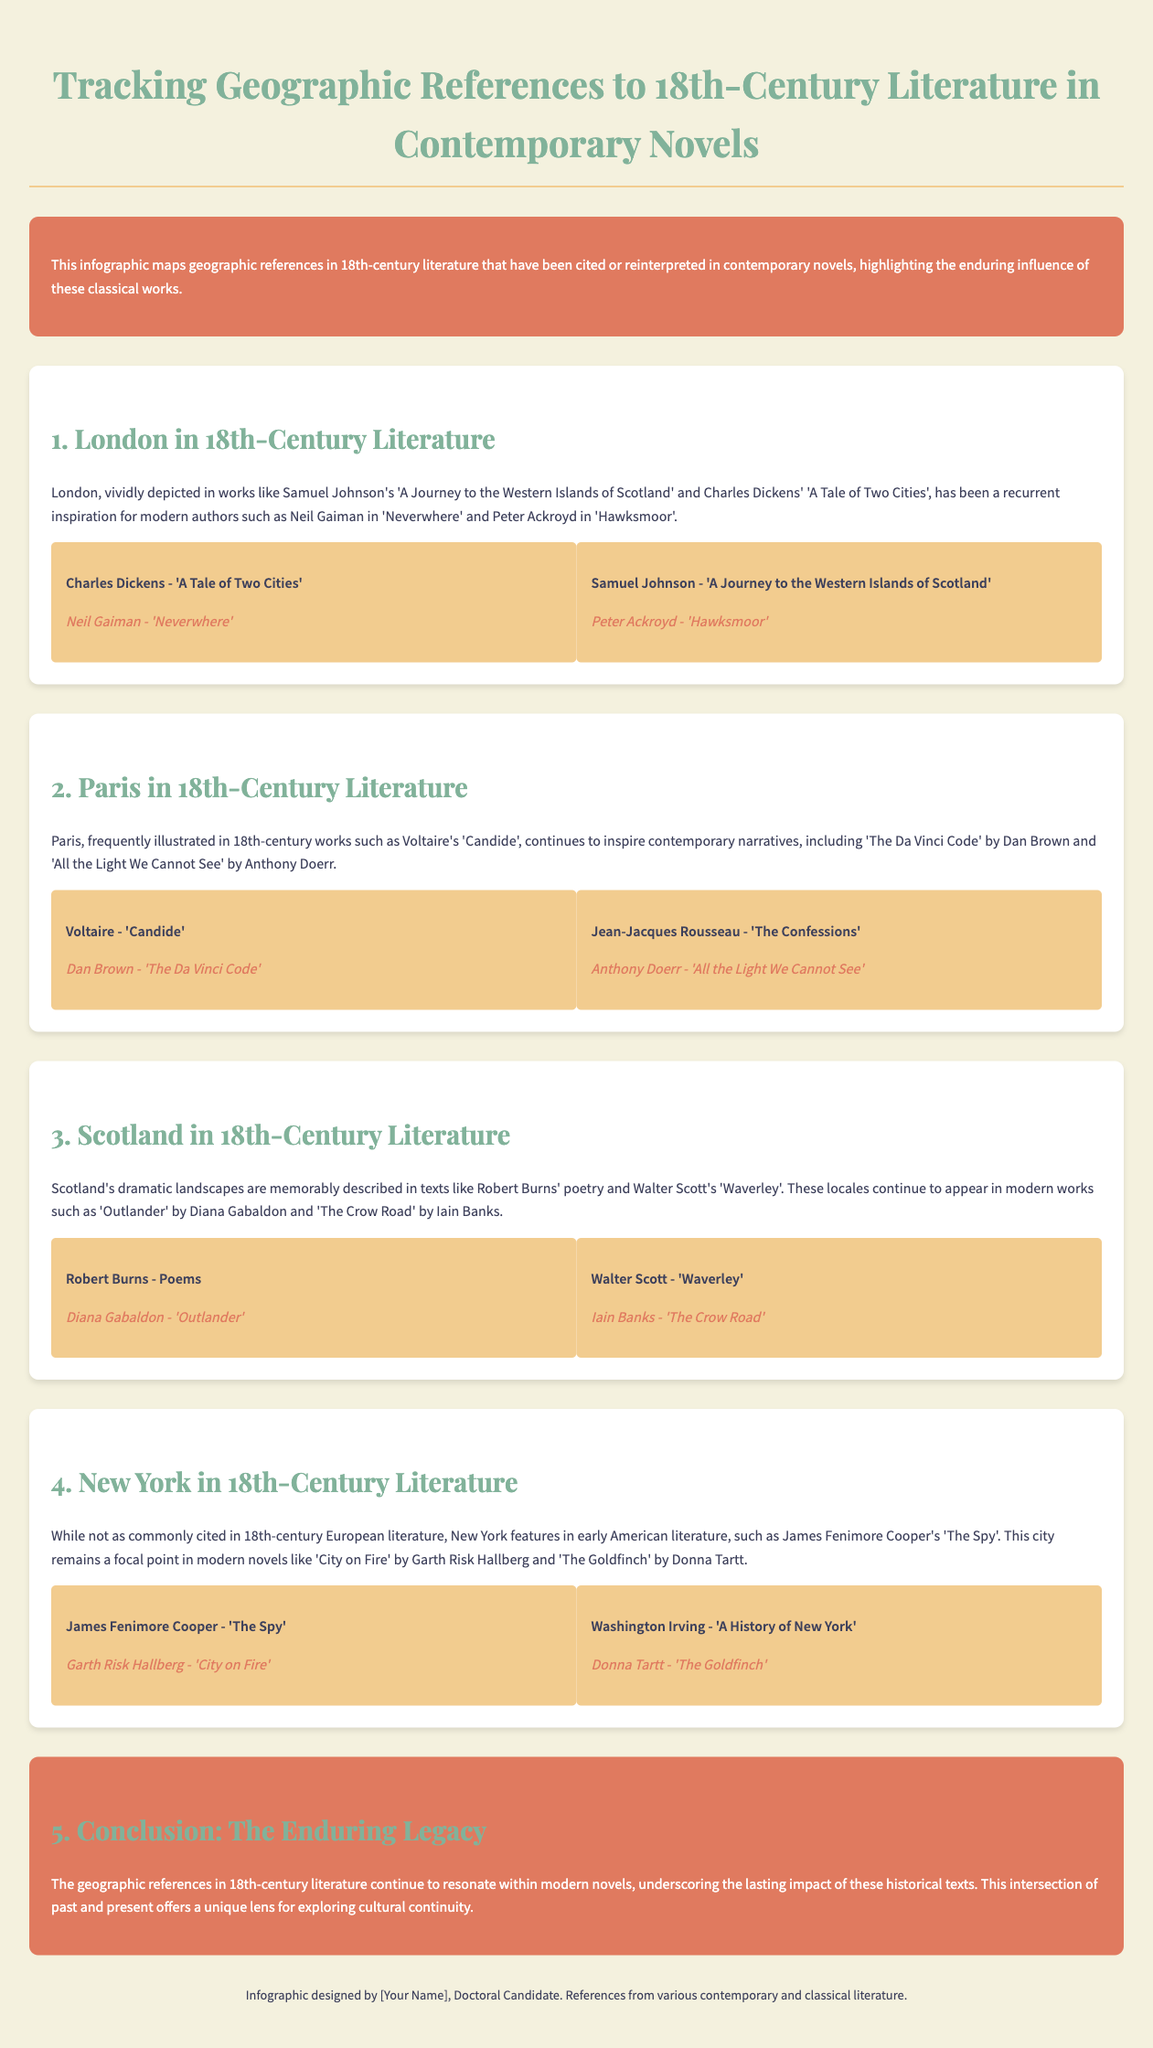What are the two historical works cited in relation to London? The document lists 'A Journey to the Western Islands of Scotland' by Samuel Johnson and 'A Tale of Two Cities' by Charles Dickens in connection with London.
Answer: 'A Journey to the Western Islands of Scotland', 'A Tale of Two Cities' Which modern author is associated with Voltaire's 'Candide'? The document states that Dan Brown is a contemporary author who draws inspiration from Voltaire's 'Candide'.
Answer: Dan Brown What is the modern novel linked to Robert Burns' poetry? According to the document, 'Outlander' by Diana Gabaldon is the modern novel associated with Robert Burns' poetry.
Answer: 'Outlander' What city is highlighted in the section about early American literature? The infographic discusses New York in the context of early American literature, specifically citing James Fenimore Cooper's 'The Spy'.
Answer: New York How many geographic locations are analyzed in this infographic? The document covers four geographic locations: London, Paris, Scotland, and New York, indicating a total of four areas analyzed.
Answer: Four 